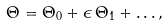<formula> <loc_0><loc_0><loc_500><loc_500>\Theta = \Theta _ { 0 } + \epsilon \, \Theta _ { 1 } + \dots ,</formula> 